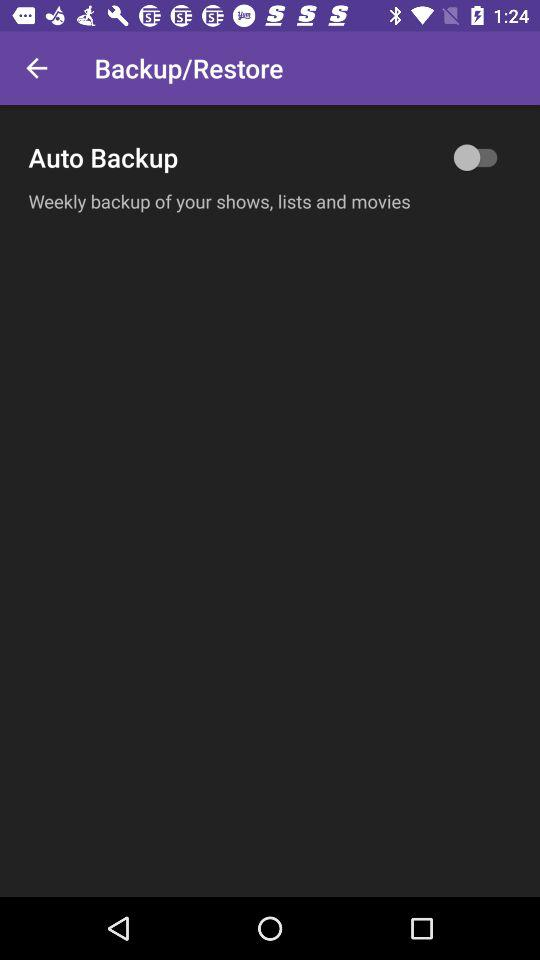How often is auto backup happening?
When the provided information is insufficient, respond with <no answer>. <no answer> 